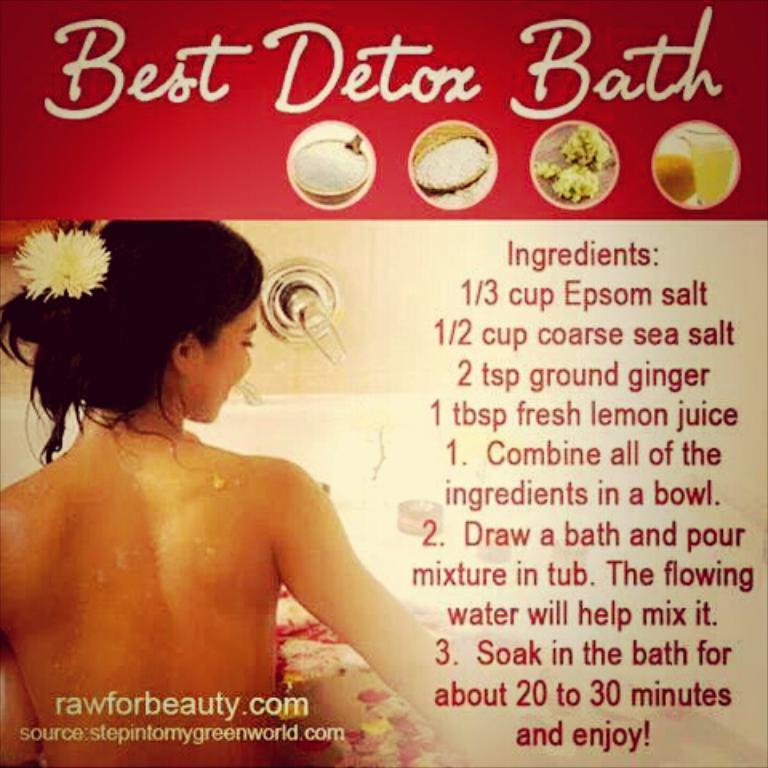What is present in the image that contains information or a message? There is a poster in the image that contains text. What is the main subject of the poster? The poster depicts a person. What type of spoon is being used by the person in the poster? There is no spoon present in the image, as the poster only depicts a person and does not show any objects being used by them. 